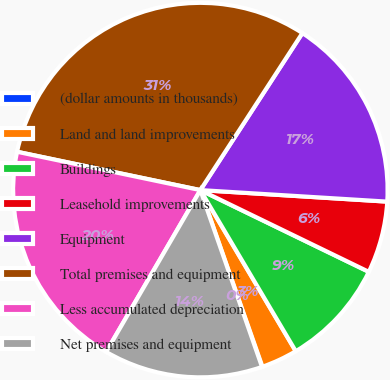Convert chart to OTSL. <chart><loc_0><loc_0><loc_500><loc_500><pie_chart><fcel>(dollar amounts in thousands)<fcel>Land and land improvements<fcel>Buildings<fcel>Leasehold improvements<fcel>Equipment<fcel>Total premises and equipment<fcel>Less accumulated depreciation<fcel>Net premises and equipment<nl><fcel>0.04%<fcel>3.13%<fcel>9.3%<fcel>6.21%<fcel>16.81%<fcel>30.89%<fcel>19.89%<fcel>13.73%<nl></chart> 